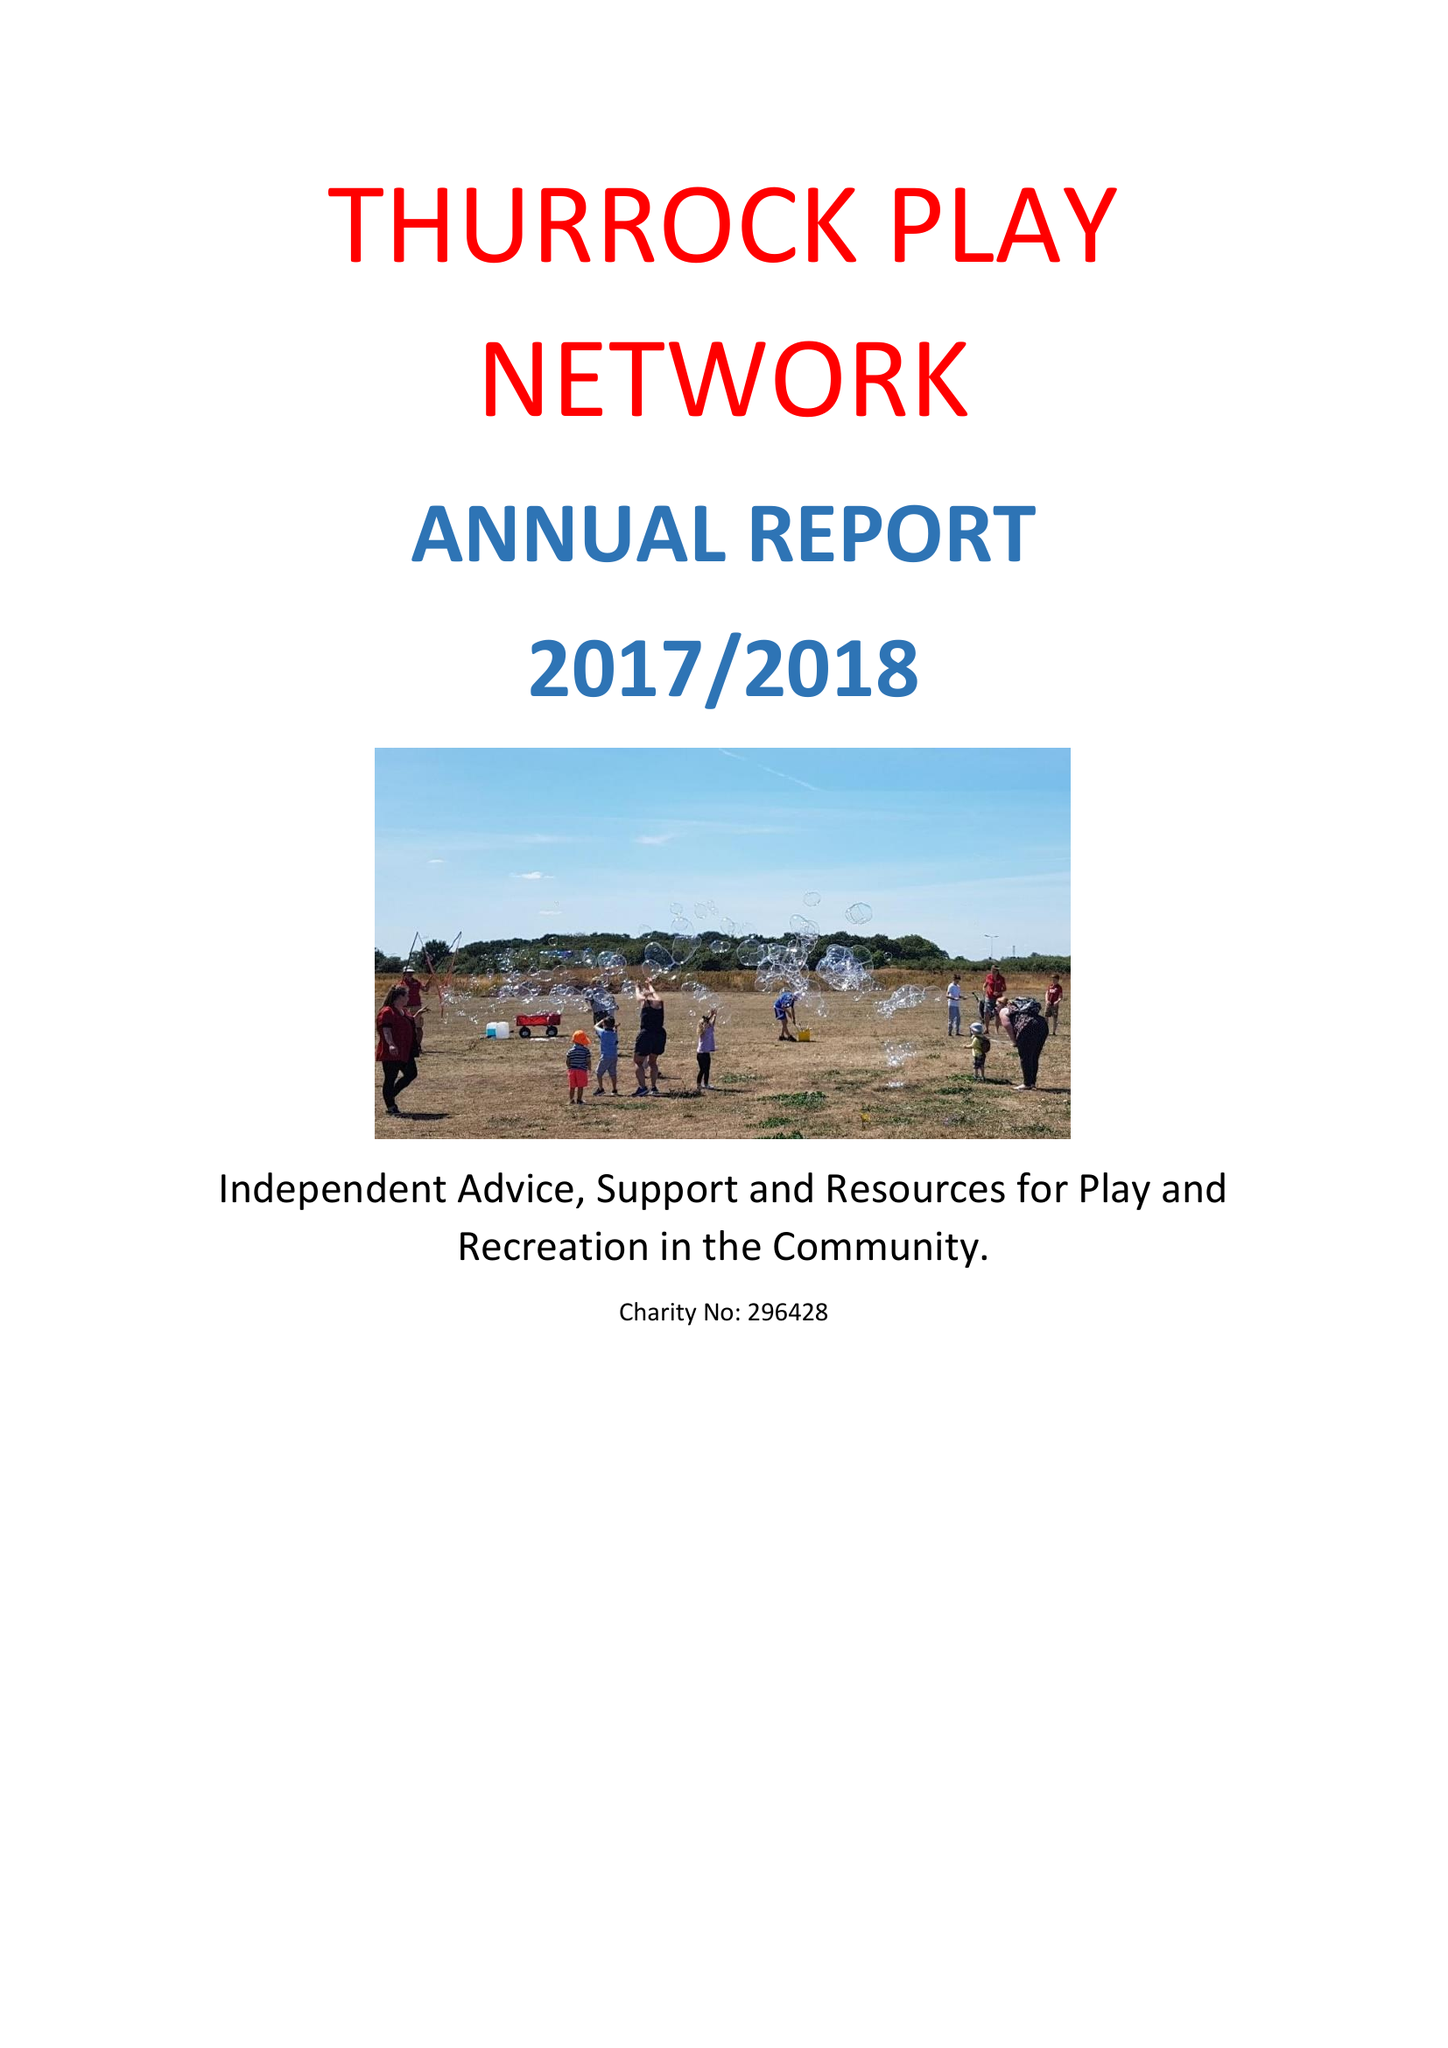What is the value for the report_date?
Answer the question using a single word or phrase. 2018-03-31 